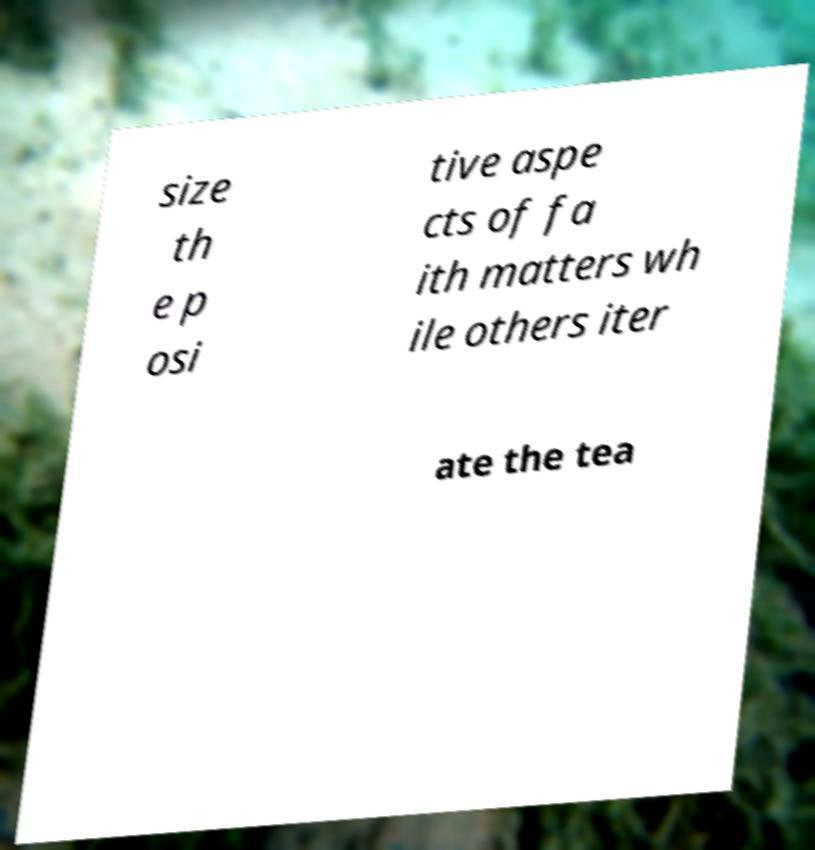Can you accurately transcribe the text from the provided image for me? size th e p osi tive aspe cts of fa ith matters wh ile others iter ate the tea 